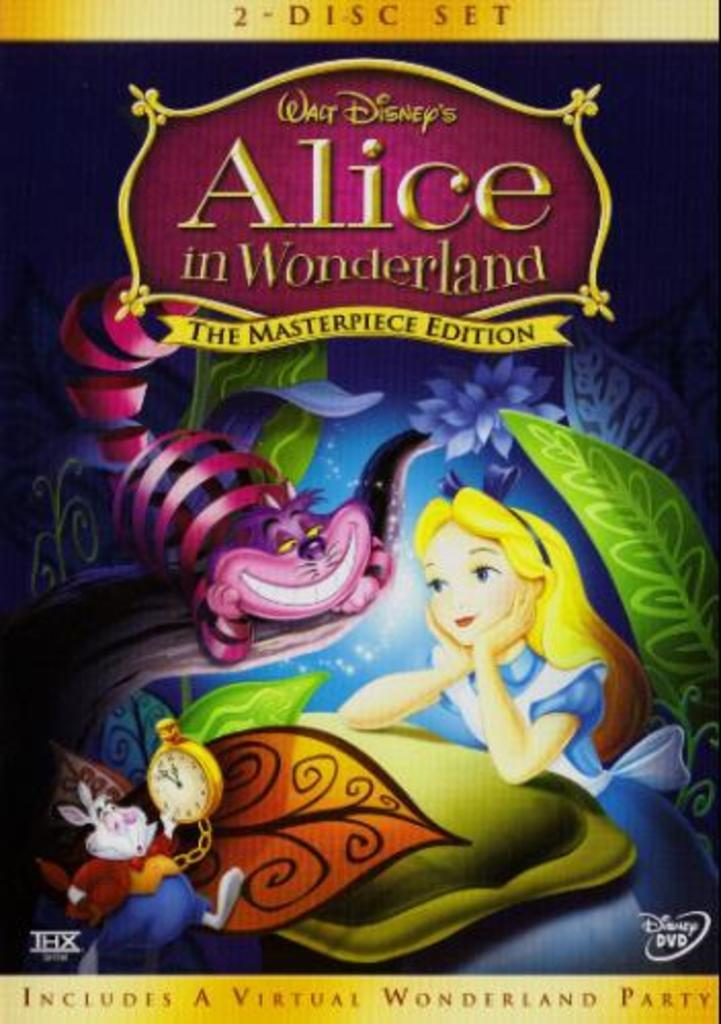<image>
Share a concise interpretation of the image provided. Cover for a movie which says Alice in Wonderland on it. 